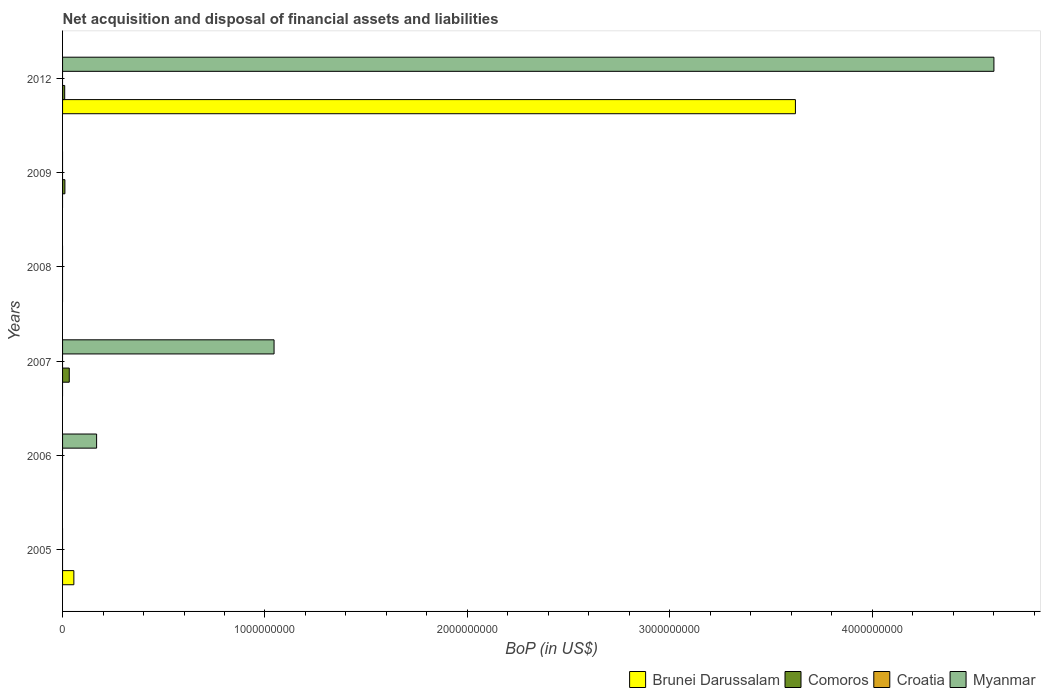Are the number of bars per tick equal to the number of legend labels?
Keep it short and to the point. No. Are the number of bars on each tick of the Y-axis equal?
Your response must be concise. No. How many bars are there on the 6th tick from the top?
Provide a succinct answer. 1. What is the label of the 2nd group of bars from the top?
Your answer should be compact. 2009. In how many cases, is the number of bars for a given year not equal to the number of legend labels?
Offer a very short reply. 6. What is the Balance of Payments in Brunei Darussalam in 2012?
Ensure brevity in your answer.  3.62e+09. Across all years, what is the maximum Balance of Payments in Comoros?
Give a very brief answer. 3.31e+07. Across all years, what is the minimum Balance of Payments in Comoros?
Your response must be concise. 0. In which year was the Balance of Payments in Brunei Darussalam maximum?
Keep it short and to the point. 2012. What is the total Balance of Payments in Comoros in the graph?
Provide a short and direct response. 5.52e+07. What is the difference between the Balance of Payments in Croatia in 2006 and the Balance of Payments in Comoros in 2008?
Provide a succinct answer. 0. What is the average Balance of Payments in Brunei Darussalam per year?
Provide a succinct answer. 6.13e+08. Is the Balance of Payments in Comoros in 2007 less than that in 2009?
Offer a very short reply. No. What is the difference between the highest and the lowest Balance of Payments in Brunei Darussalam?
Keep it short and to the point. 3.62e+09. In how many years, is the Balance of Payments in Croatia greater than the average Balance of Payments in Croatia taken over all years?
Offer a terse response. 0. Is it the case that in every year, the sum of the Balance of Payments in Myanmar and Balance of Payments in Brunei Darussalam is greater than the Balance of Payments in Comoros?
Provide a succinct answer. No. How many bars are there?
Offer a terse response. 8. How many years are there in the graph?
Keep it short and to the point. 6. What is the difference between two consecutive major ticks on the X-axis?
Your answer should be very brief. 1.00e+09. Are the values on the major ticks of X-axis written in scientific E-notation?
Give a very brief answer. No. Where does the legend appear in the graph?
Offer a very short reply. Bottom right. What is the title of the graph?
Provide a short and direct response. Net acquisition and disposal of financial assets and liabilities. What is the label or title of the X-axis?
Provide a succinct answer. BoP (in US$). What is the label or title of the Y-axis?
Make the answer very short. Years. What is the BoP (in US$) in Brunei Darussalam in 2005?
Offer a terse response. 5.58e+07. What is the BoP (in US$) of Croatia in 2005?
Offer a very short reply. 0. What is the BoP (in US$) of Myanmar in 2005?
Provide a succinct answer. 0. What is the BoP (in US$) in Brunei Darussalam in 2006?
Your answer should be compact. 0. What is the BoP (in US$) of Myanmar in 2006?
Make the answer very short. 1.68e+08. What is the BoP (in US$) of Comoros in 2007?
Your response must be concise. 3.31e+07. What is the BoP (in US$) in Croatia in 2007?
Keep it short and to the point. 0. What is the BoP (in US$) in Myanmar in 2007?
Your response must be concise. 1.05e+09. What is the BoP (in US$) in Brunei Darussalam in 2008?
Your answer should be very brief. 0. What is the BoP (in US$) of Croatia in 2008?
Ensure brevity in your answer.  0. What is the BoP (in US$) of Myanmar in 2008?
Provide a succinct answer. 0. What is the BoP (in US$) in Comoros in 2009?
Your answer should be compact. 1.15e+07. What is the BoP (in US$) of Myanmar in 2009?
Offer a terse response. 0. What is the BoP (in US$) of Brunei Darussalam in 2012?
Ensure brevity in your answer.  3.62e+09. What is the BoP (in US$) in Comoros in 2012?
Make the answer very short. 1.05e+07. What is the BoP (in US$) in Croatia in 2012?
Provide a succinct answer. 0. What is the BoP (in US$) in Myanmar in 2012?
Your response must be concise. 4.60e+09. Across all years, what is the maximum BoP (in US$) of Brunei Darussalam?
Keep it short and to the point. 3.62e+09. Across all years, what is the maximum BoP (in US$) of Comoros?
Your answer should be very brief. 3.31e+07. Across all years, what is the maximum BoP (in US$) of Myanmar?
Provide a short and direct response. 4.60e+09. Across all years, what is the minimum BoP (in US$) in Brunei Darussalam?
Your response must be concise. 0. Across all years, what is the minimum BoP (in US$) in Comoros?
Make the answer very short. 0. Across all years, what is the minimum BoP (in US$) of Myanmar?
Provide a short and direct response. 0. What is the total BoP (in US$) of Brunei Darussalam in the graph?
Offer a terse response. 3.68e+09. What is the total BoP (in US$) of Comoros in the graph?
Provide a short and direct response. 5.52e+07. What is the total BoP (in US$) of Myanmar in the graph?
Give a very brief answer. 5.82e+09. What is the difference between the BoP (in US$) in Brunei Darussalam in 2005 and that in 2012?
Offer a very short reply. -3.57e+09. What is the difference between the BoP (in US$) in Myanmar in 2006 and that in 2007?
Offer a very short reply. -8.77e+08. What is the difference between the BoP (in US$) of Myanmar in 2006 and that in 2012?
Ensure brevity in your answer.  -4.43e+09. What is the difference between the BoP (in US$) in Comoros in 2007 and that in 2009?
Keep it short and to the point. 2.16e+07. What is the difference between the BoP (in US$) of Comoros in 2007 and that in 2012?
Give a very brief answer. 2.25e+07. What is the difference between the BoP (in US$) of Myanmar in 2007 and that in 2012?
Provide a succinct answer. -3.56e+09. What is the difference between the BoP (in US$) in Comoros in 2009 and that in 2012?
Keep it short and to the point. 9.90e+05. What is the difference between the BoP (in US$) in Brunei Darussalam in 2005 and the BoP (in US$) in Myanmar in 2006?
Your answer should be compact. -1.12e+08. What is the difference between the BoP (in US$) in Brunei Darussalam in 2005 and the BoP (in US$) in Comoros in 2007?
Make the answer very short. 2.27e+07. What is the difference between the BoP (in US$) of Brunei Darussalam in 2005 and the BoP (in US$) of Myanmar in 2007?
Offer a very short reply. -9.89e+08. What is the difference between the BoP (in US$) in Brunei Darussalam in 2005 and the BoP (in US$) in Comoros in 2009?
Your answer should be compact. 4.43e+07. What is the difference between the BoP (in US$) in Brunei Darussalam in 2005 and the BoP (in US$) in Comoros in 2012?
Provide a short and direct response. 4.53e+07. What is the difference between the BoP (in US$) of Brunei Darussalam in 2005 and the BoP (in US$) of Myanmar in 2012?
Keep it short and to the point. -4.55e+09. What is the difference between the BoP (in US$) of Comoros in 2007 and the BoP (in US$) of Myanmar in 2012?
Keep it short and to the point. -4.57e+09. What is the difference between the BoP (in US$) in Comoros in 2009 and the BoP (in US$) in Myanmar in 2012?
Offer a very short reply. -4.59e+09. What is the average BoP (in US$) of Brunei Darussalam per year?
Offer a terse response. 6.13e+08. What is the average BoP (in US$) of Comoros per year?
Keep it short and to the point. 9.19e+06. What is the average BoP (in US$) in Croatia per year?
Your answer should be compact. 0. What is the average BoP (in US$) of Myanmar per year?
Offer a terse response. 9.69e+08. In the year 2007, what is the difference between the BoP (in US$) of Comoros and BoP (in US$) of Myanmar?
Your answer should be very brief. -1.01e+09. In the year 2012, what is the difference between the BoP (in US$) in Brunei Darussalam and BoP (in US$) in Comoros?
Offer a very short reply. 3.61e+09. In the year 2012, what is the difference between the BoP (in US$) of Brunei Darussalam and BoP (in US$) of Myanmar?
Ensure brevity in your answer.  -9.81e+08. In the year 2012, what is the difference between the BoP (in US$) of Comoros and BoP (in US$) of Myanmar?
Offer a very short reply. -4.59e+09. What is the ratio of the BoP (in US$) of Brunei Darussalam in 2005 to that in 2012?
Ensure brevity in your answer.  0.02. What is the ratio of the BoP (in US$) of Myanmar in 2006 to that in 2007?
Your response must be concise. 0.16. What is the ratio of the BoP (in US$) of Myanmar in 2006 to that in 2012?
Offer a terse response. 0.04. What is the ratio of the BoP (in US$) in Comoros in 2007 to that in 2009?
Give a very brief answer. 2.87. What is the ratio of the BoP (in US$) of Comoros in 2007 to that in 2012?
Offer a very short reply. 3.14. What is the ratio of the BoP (in US$) in Myanmar in 2007 to that in 2012?
Give a very brief answer. 0.23. What is the ratio of the BoP (in US$) in Comoros in 2009 to that in 2012?
Give a very brief answer. 1.09. What is the difference between the highest and the second highest BoP (in US$) in Comoros?
Offer a terse response. 2.16e+07. What is the difference between the highest and the second highest BoP (in US$) of Myanmar?
Your response must be concise. 3.56e+09. What is the difference between the highest and the lowest BoP (in US$) of Brunei Darussalam?
Your answer should be very brief. 3.62e+09. What is the difference between the highest and the lowest BoP (in US$) of Comoros?
Provide a short and direct response. 3.31e+07. What is the difference between the highest and the lowest BoP (in US$) of Myanmar?
Give a very brief answer. 4.60e+09. 